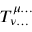Convert formula to latex. <formula><loc_0><loc_0><loc_500><loc_500>T _ { \nu \dots } ^ { \mu \dots }</formula> 